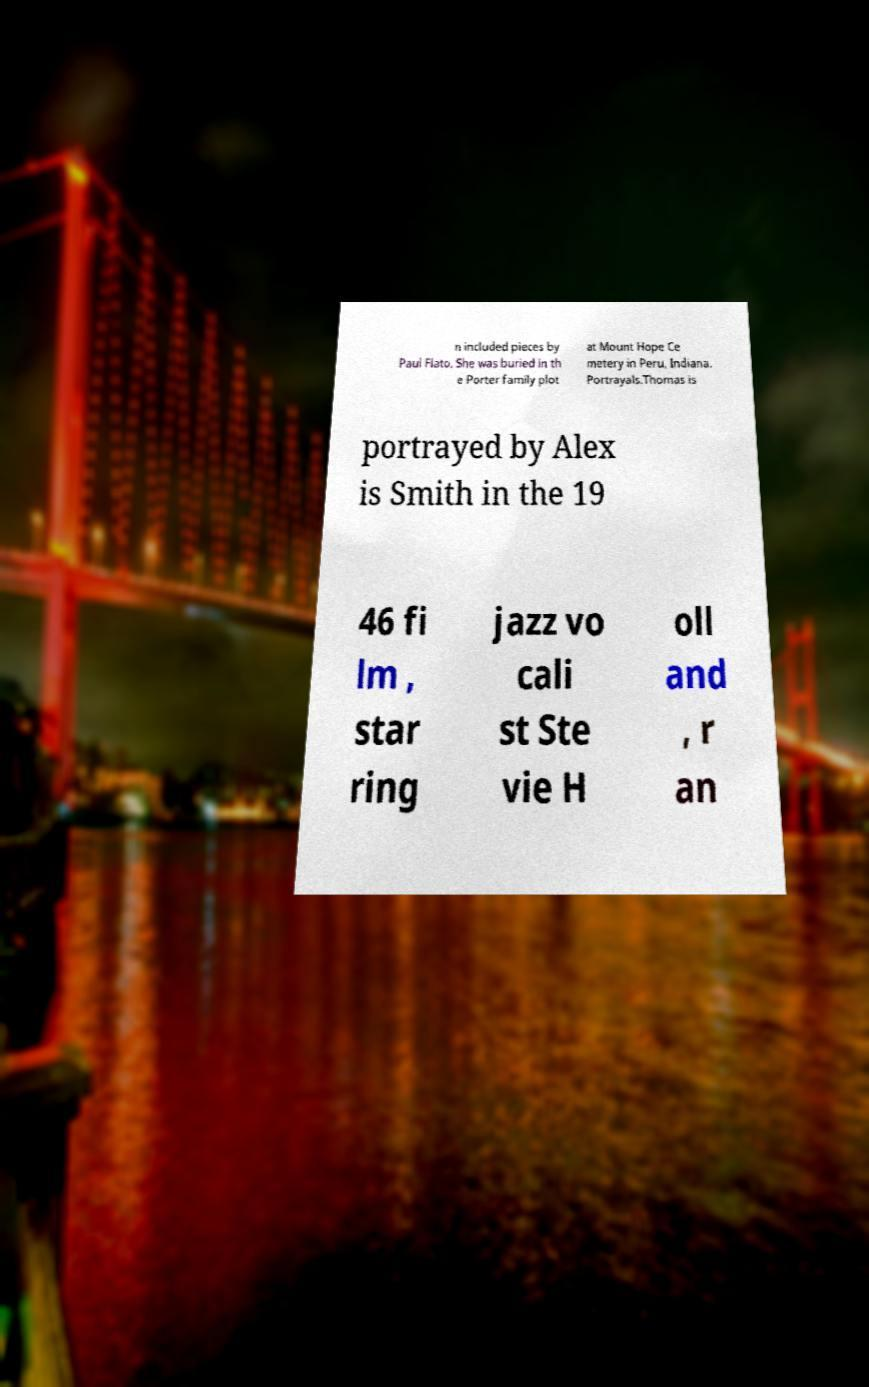I need the written content from this picture converted into text. Can you do that? n included pieces by Paul Flato. She was buried in th e Porter family plot at Mount Hope Ce metery in Peru, Indiana. Portrayals.Thomas is portrayed by Alex is Smith in the 19 46 fi lm , star ring jazz vo cali st Ste vie H oll and , r an 